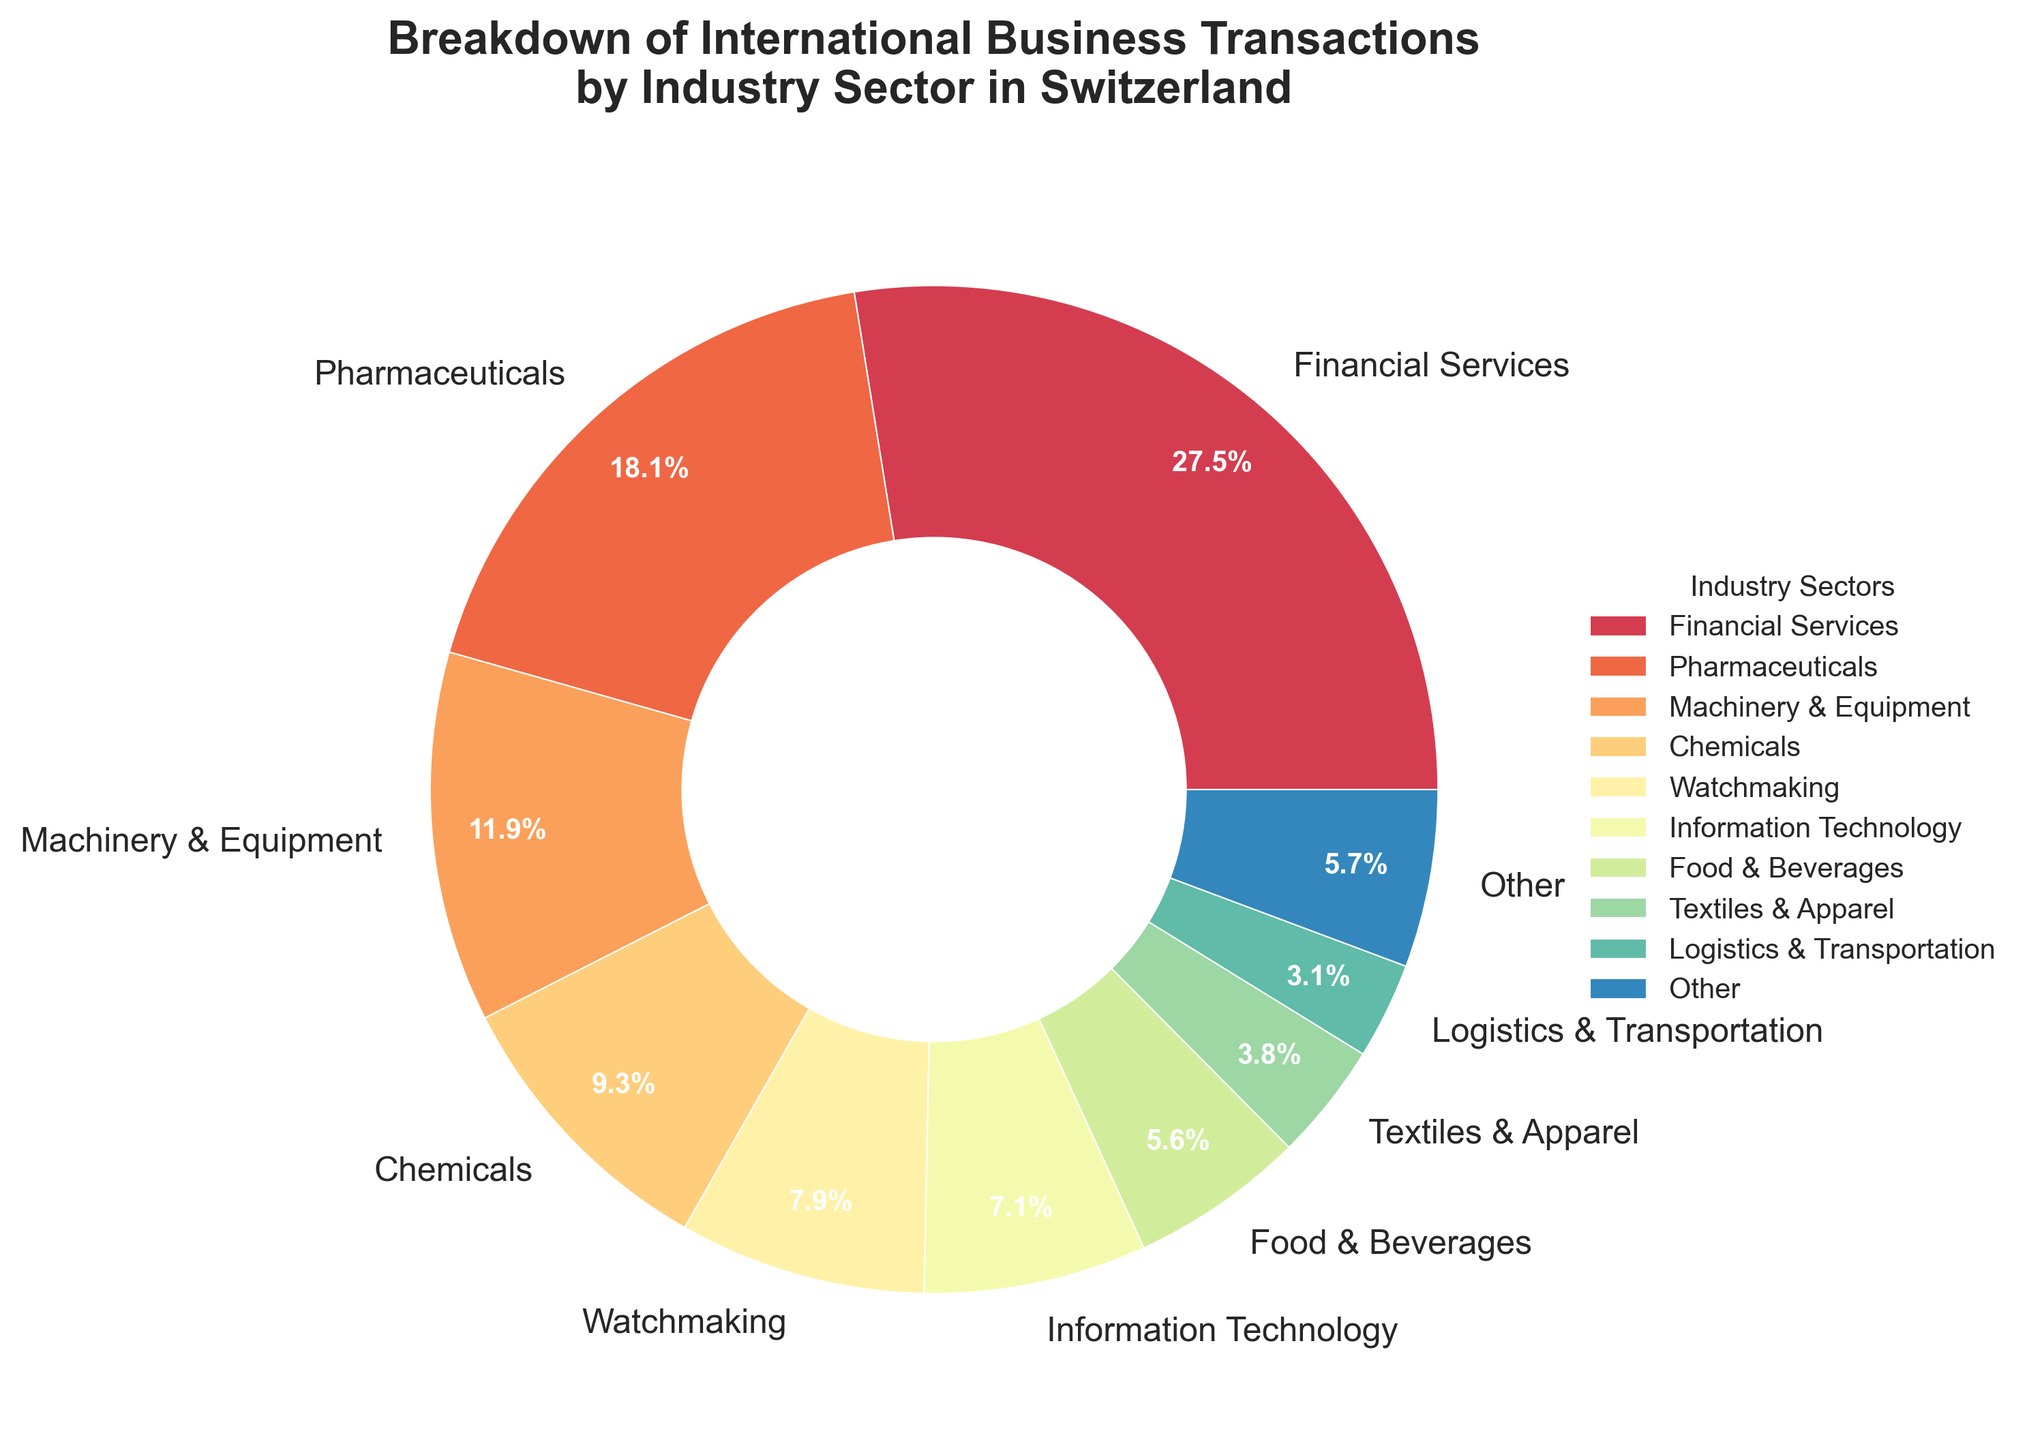What percentage of international business transactions are in the Financial Services sector? The percentage is directly provided in the pie chart segment labeled as 'Financial Services'.
Answer: 28.5% Which industry has the second-largest share of international business transactions in Switzerland? By comparing the pie chart segments, the segment labeled 'Pharmaceuticals' is the second largest.
Answer: Pharmaceuticals What is the combined percentage of international business transactions for the Financial Services and Pharmaceuticals sectors? Add the percentages of Financial Services and Pharmaceuticals from the pie chart: 28.5% + 18.7%.
Answer: 47.2% How much larger is the percentage of the Financial Services sector compared to the Hospitality & Tourism sector? Subtract the percentage of Hospitality & Tourism from the percentage of Financial Services: 28.5% - 1.3%.
Answer: 27.2% If 'Other' includes Logistics & Transportation, Biotechnology, Renewable Energy, Hospitality & Tourism, and Automotive, what is the combined percentage for these sectors? Sum the percentages of the sectors included in 'Other': 3.2% + 2.4% + 1.5% + 1.3% + 0.7%.
Answer: 9.1% What is the total percentage of international business transactions for sectors with a share less than 10%? Add the percentages of all sectors except Financial Services, Pharmaceuticals, and Machinery & Equipment: 9.6% + 8.2% + 7.4% + 5.8% + 3.9% + 3.2% + 2.4% + 1.5% + 1.3% + 0.7%.
Answer: 44% Is the percentage of Food & Beverages sector larger or smaller than the Watchmaking sector? Compare the percentages directly from the pie chart segments labeled as 'Food & Beverages' and 'Watchmaking'. Food & Beverages (5.8%) is smaller than Watchmaking (8.2%).
Answer: Smaller How does the percentage of Machinery & Equipment compare to the combined percentage of Textiles & Apparel and Information Technology? Sum the percentages of Textiles & Apparel and Information Technology: 3.9% + 7.4% = 11.3%. Machinery & Equipment is at 12.3%, which is larger.
Answer: Larger What sectors are included in the 'Other' category and what is their total collective percentage? The 'Other' category combines sectors with less than 3% each: Logistics & Transportation (3.2%), Biotechnology (2.4%), Renewable Energy (1.5%), Hospitality & Tourism (1.3%), and Automotive (0.7%). Their collective percentage is 9.1%.
Answer: Logistics & Transportation, Biotechnology, Renewable Energy, Hospitality & Tourism, Automotive; 9.1% Which sector appears with the most vibrant color visually in the pie chart? By looking at the visual representation, Financial Services is often colored with a vibrant hue for emphasizing its large share.
Answer: Financial Services 